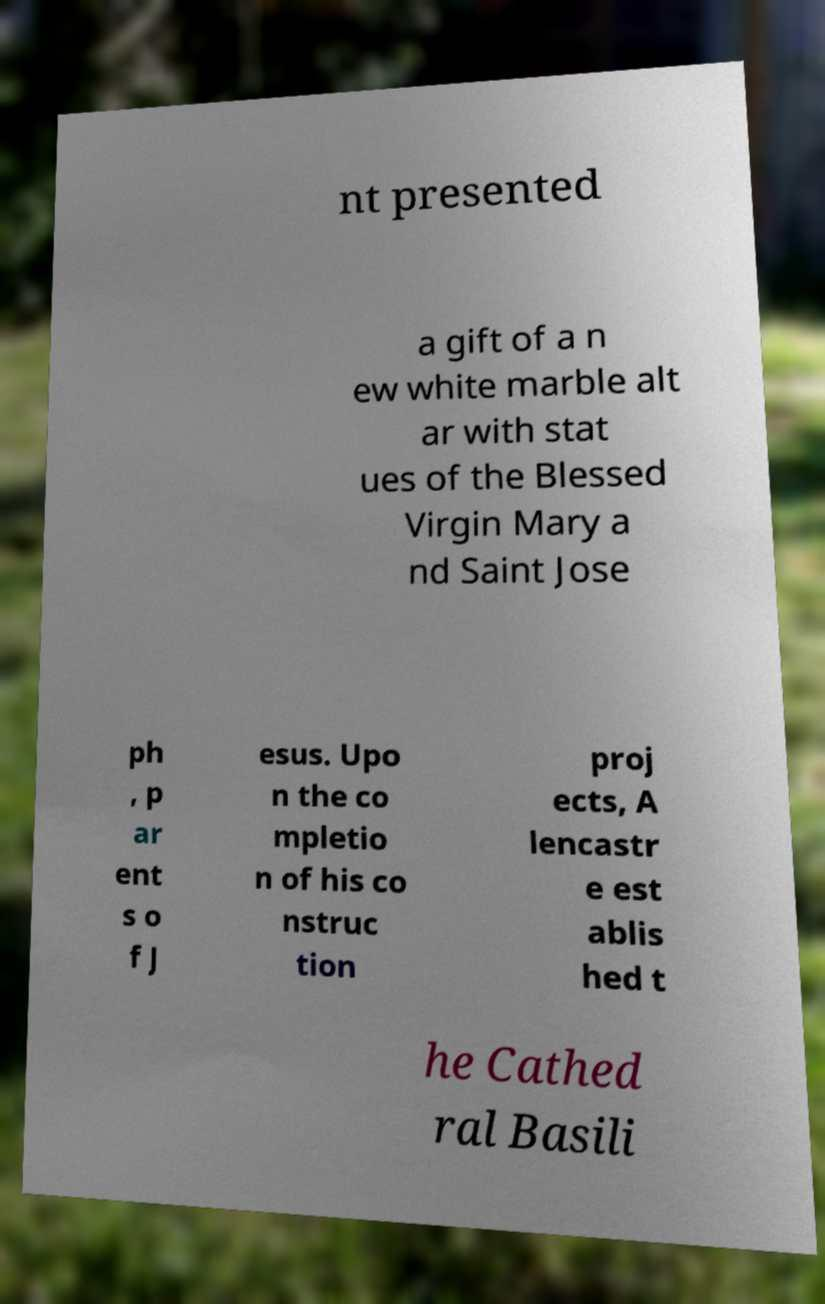There's text embedded in this image that I need extracted. Can you transcribe it verbatim? nt presented a gift of a n ew white marble alt ar with stat ues of the Blessed Virgin Mary a nd Saint Jose ph , p ar ent s o f J esus. Upo n the co mpletio n of his co nstruc tion proj ects, A lencastr e est ablis hed t he Cathed ral Basili 